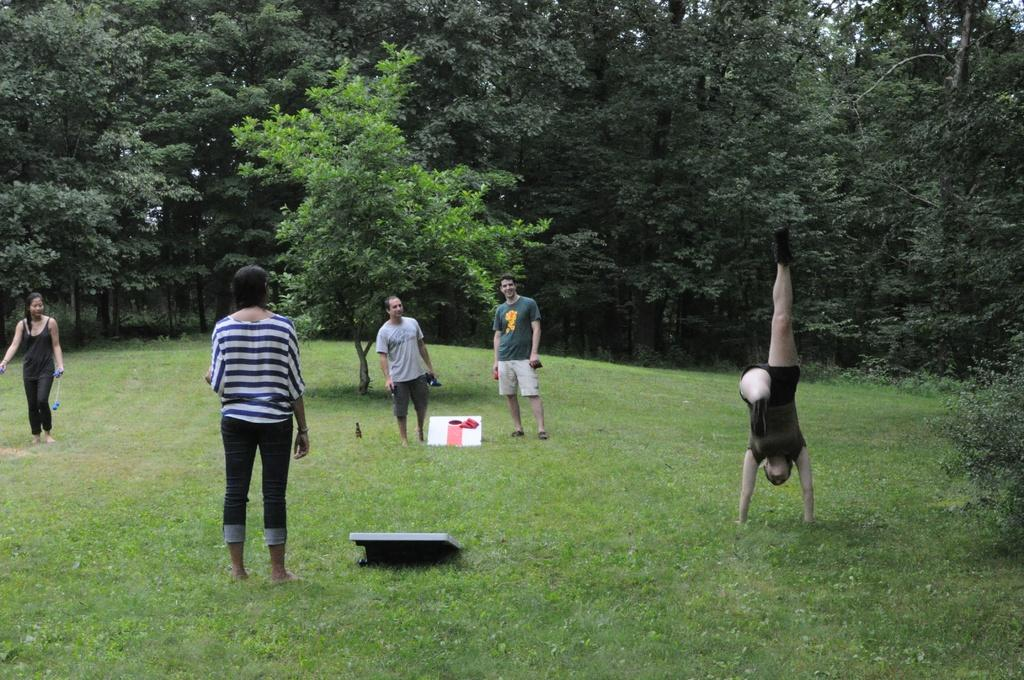What type of surface is visible on the ground in the image? There is grass on the ground in the image. What color is the grass? The grass is green in color. Can you describe the people in the image? There are people standing in the image. What can be seen in the background of the image? There are green color trees in the background of the image. What type of form or payment is being exchanged between the people in the image? There is no indication of any form or payment being exchanged between the people in the image. What meal is being prepared or served in the image? There is no meal preparation or serving visible in the image. 